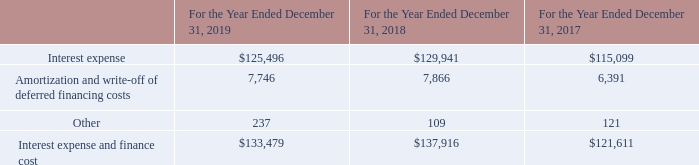NAVIOS MARITIME HOLDINGS INC. NOTES TO THE CONSOLIDATED FINANCIAL STATEMENTS (Expressed in thousands of U.S. dollars — except share data)
NOTE 18: INTEREST EXPENSE AND FINANCE COST
Interest expense and finance cost consisted of the following:
Which years does the table provide information for the company's Interest expense and finance cost? 2019, 2018, 2017. What was the Amortization and write-off of deferred financing costs in 2019?
Answer scale should be: thousand. 7,746. What was the Interest expense and finance cost in 2017?
Answer scale should be: thousand. 121,611. How many years did Other expense and cost exceed $100 thousand? 2019##2018##2017
Answer: 3. What was the change in Interest expense between 2017 and 2018?
Answer scale should be: thousand. 129,941-115,099
Answer: 14842. What was the percentage change in the Interest expense and finance cost between 2018 and 2019?
Answer scale should be: percent. (133,479-137,916)/137,916
Answer: -3.22. 